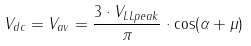Convert formula to latex. <formula><loc_0><loc_0><loc_500><loc_500>V _ { d c } = V _ { a v } = { \frac { 3 \cdot V _ { L L p e a k } } { \pi } } \cdot \cos ( \alpha + \mu )</formula> 